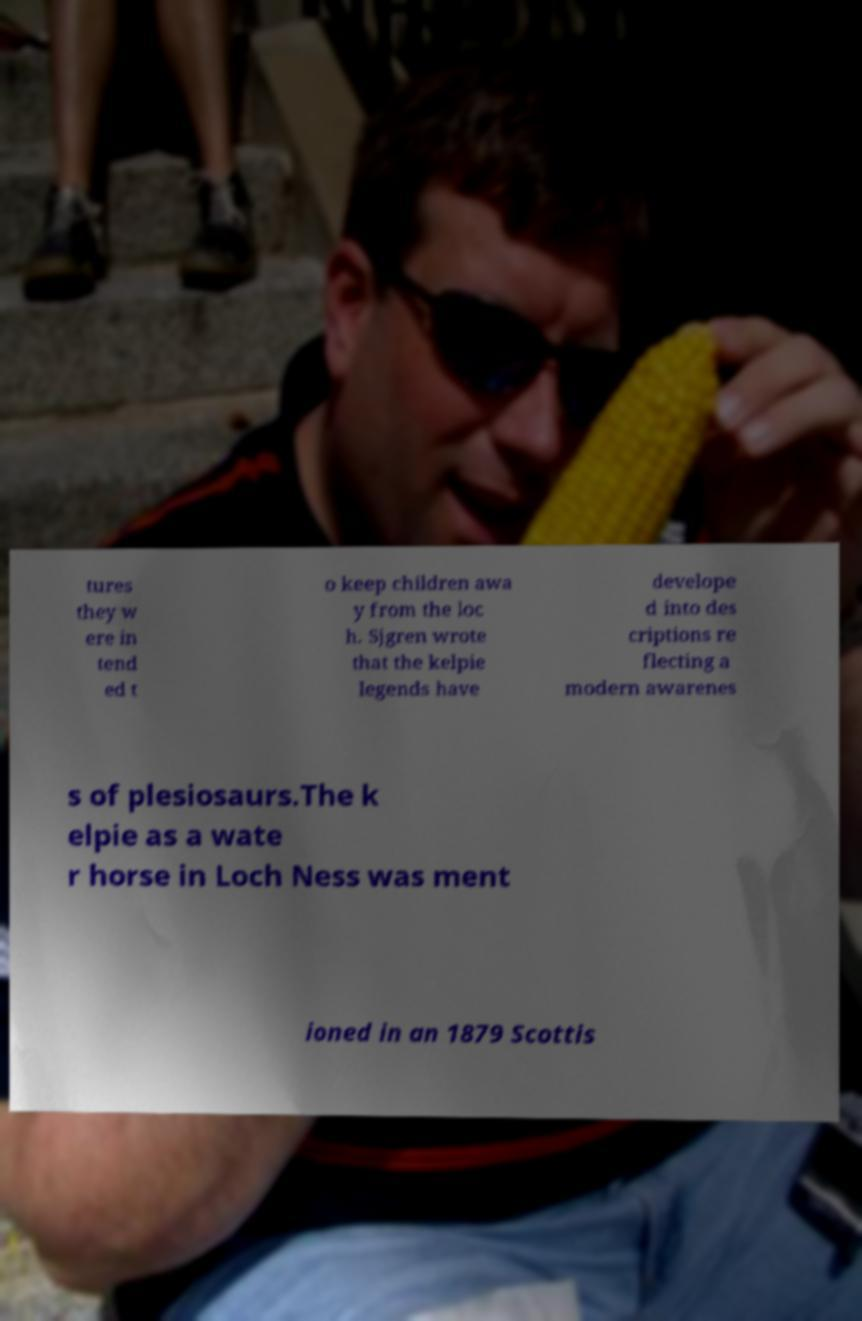Could you assist in decoding the text presented in this image and type it out clearly? tures they w ere in tend ed t o keep children awa y from the loc h. Sjgren wrote that the kelpie legends have develope d into des criptions re flecting a modern awarenes s of plesiosaurs.The k elpie as a wate r horse in Loch Ness was ment ioned in an 1879 Scottis 